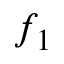Convert formula to latex. <formula><loc_0><loc_0><loc_500><loc_500>f _ { 1 }</formula> 